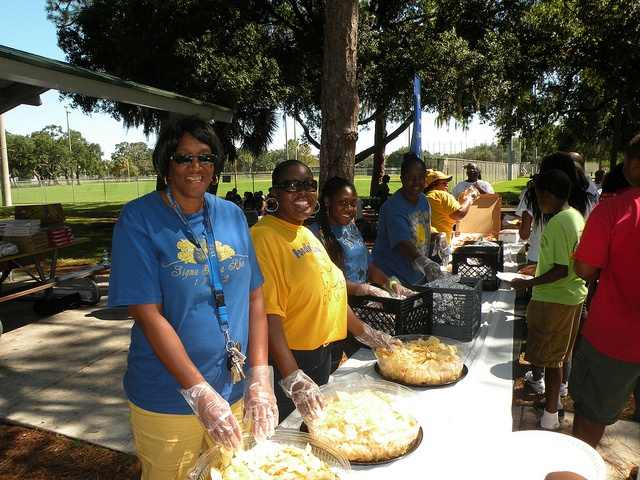Describe the objects in this image and their specific colors. I can see dining table in lightblue, white, black, khaki, and gray tones, people in lightblue, navy, black, blue, and darkblue tones, people in lightblue, orange, olive, black, and maroon tones, people in lightblue, maroon, black, and salmon tones, and people in lightblue, black, darkgreen, maroon, and gray tones in this image. 